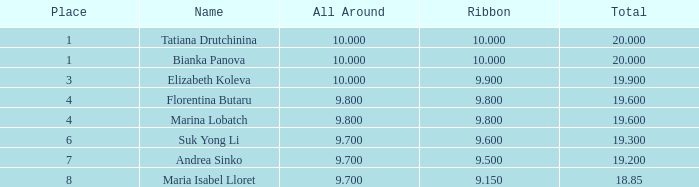8 and a 1 7.0. 